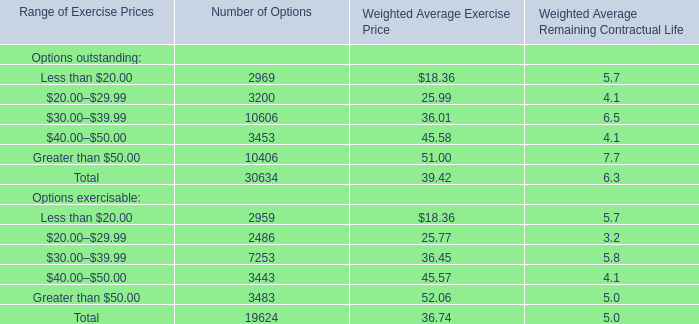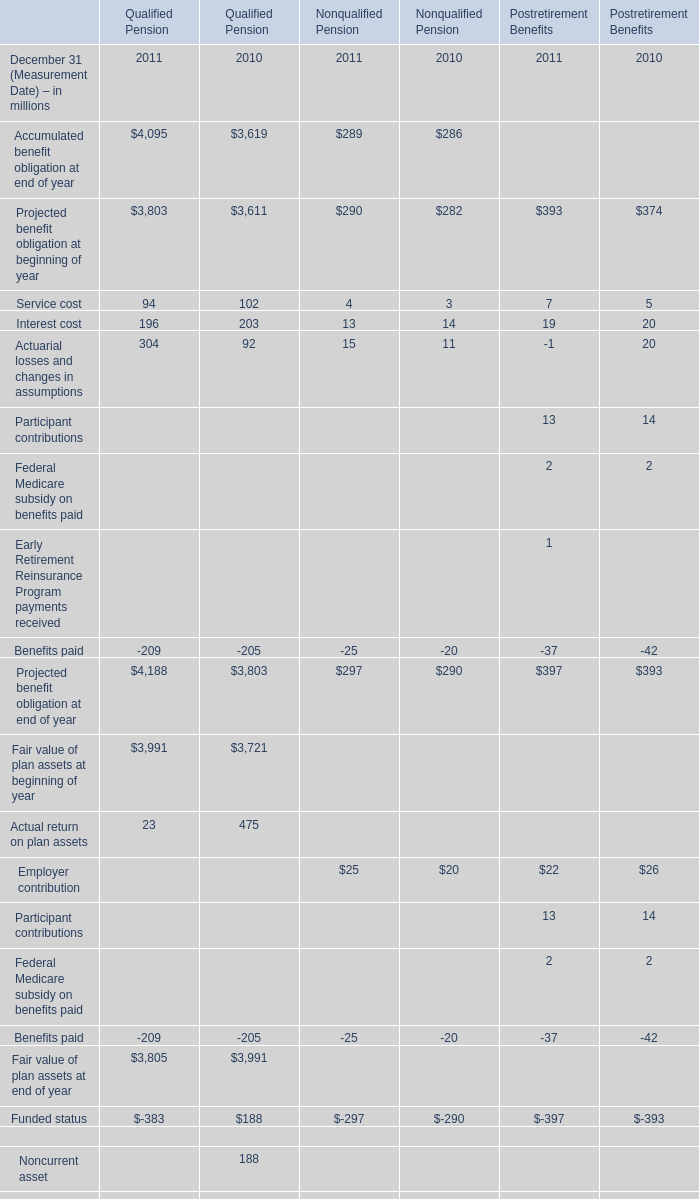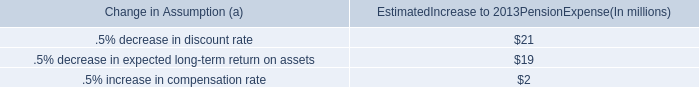If service cost develops with the same increasing rate in 2011 for qualified pension, what will it reach in 2012? (in million) 
Computations: ((((94 - 102) / 102) + 1) * 94)
Answer: 86.62745. 